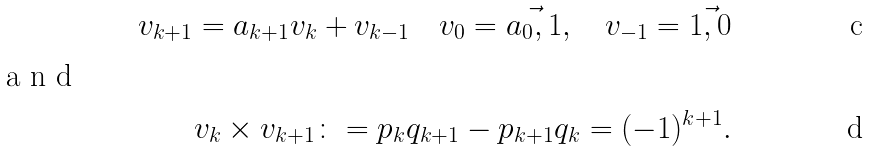Convert formula to latex. <formula><loc_0><loc_0><loc_500><loc_500>v _ { k + 1 } = a _ { k + 1 } v _ { k } + v _ { k - 1 } \quad v _ { 0 } = \vec { a _ { 0 } , 1 } , \quad v _ { - 1 } = \vec { 1 , 0 } \\ \intertext { a n d } v _ { k } \times v _ { k + 1 } \colon = p _ { k } q _ { k + 1 } - p _ { k + 1 } q _ { k } = ( - 1 ) ^ { k + 1 } .</formula> 